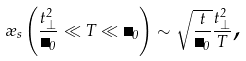Convert formula to latex. <formula><loc_0><loc_0><loc_500><loc_500>\rho _ { s } \left ( \frac { t _ { \perp } ^ { 2 } } { \Delta _ { 0 } } \ll T \ll \Delta _ { 0 } \right ) \sim \sqrt { \frac { t } { \Delta _ { 0 } } } \frac { t _ { \perp } ^ { 2 } } { T } \text {,}</formula> 